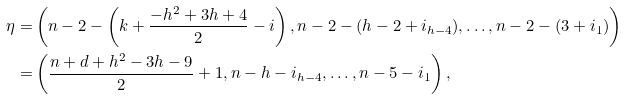<formula> <loc_0><loc_0><loc_500><loc_500>\eta = & \left ( n - 2 - \left ( k + \frac { - h ^ { 2 } + 3 h + 4 } { 2 } - i \right ) , n - 2 - ( h - 2 + i _ { h - 4 } ) , \dots , n - 2 - ( 3 + i _ { 1 } ) \right ) \\ = & \left ( \frac { n + d + h ^ { 2 } - 3 h - 9 } { 2 } + 1 , n - h - i _ { h - 4 } , \dots , n - 5 - i _ { 1 } \right ) ,</formula> 